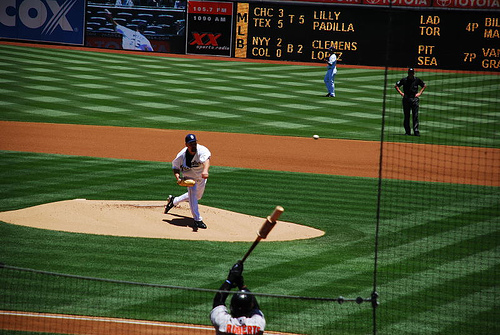Who conducts baseball league?
A. iit
B. tts
C. nht
D. mlb
Answer with the option's letter from the given choices directly. D 